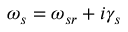Convert formula to latex. <formula><loc_0><loc_0><loc_500><loc_500>\omega _ { s } = \omega _ { s r } + i \gamma _ { s }</formula> 